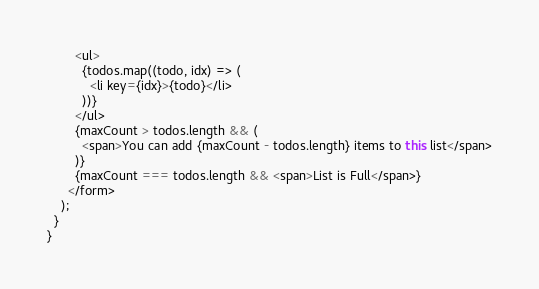Convert code to text. <code><loc_0><loc_0><loc_500><loc_500><_JavaScript_>        <ul>
          {todos.map((todo, idx) => (
            <li key={idx}>{todo}</li>
          ))}
        </ul>
        {maxCount > todos.length && (
          <span>You can add {maxCount - todos.length} items to this list</span>
        )}
        {maxCount === todos.length && <span>List is Full</span>}
      </form>
    );
  }
}
</code> 